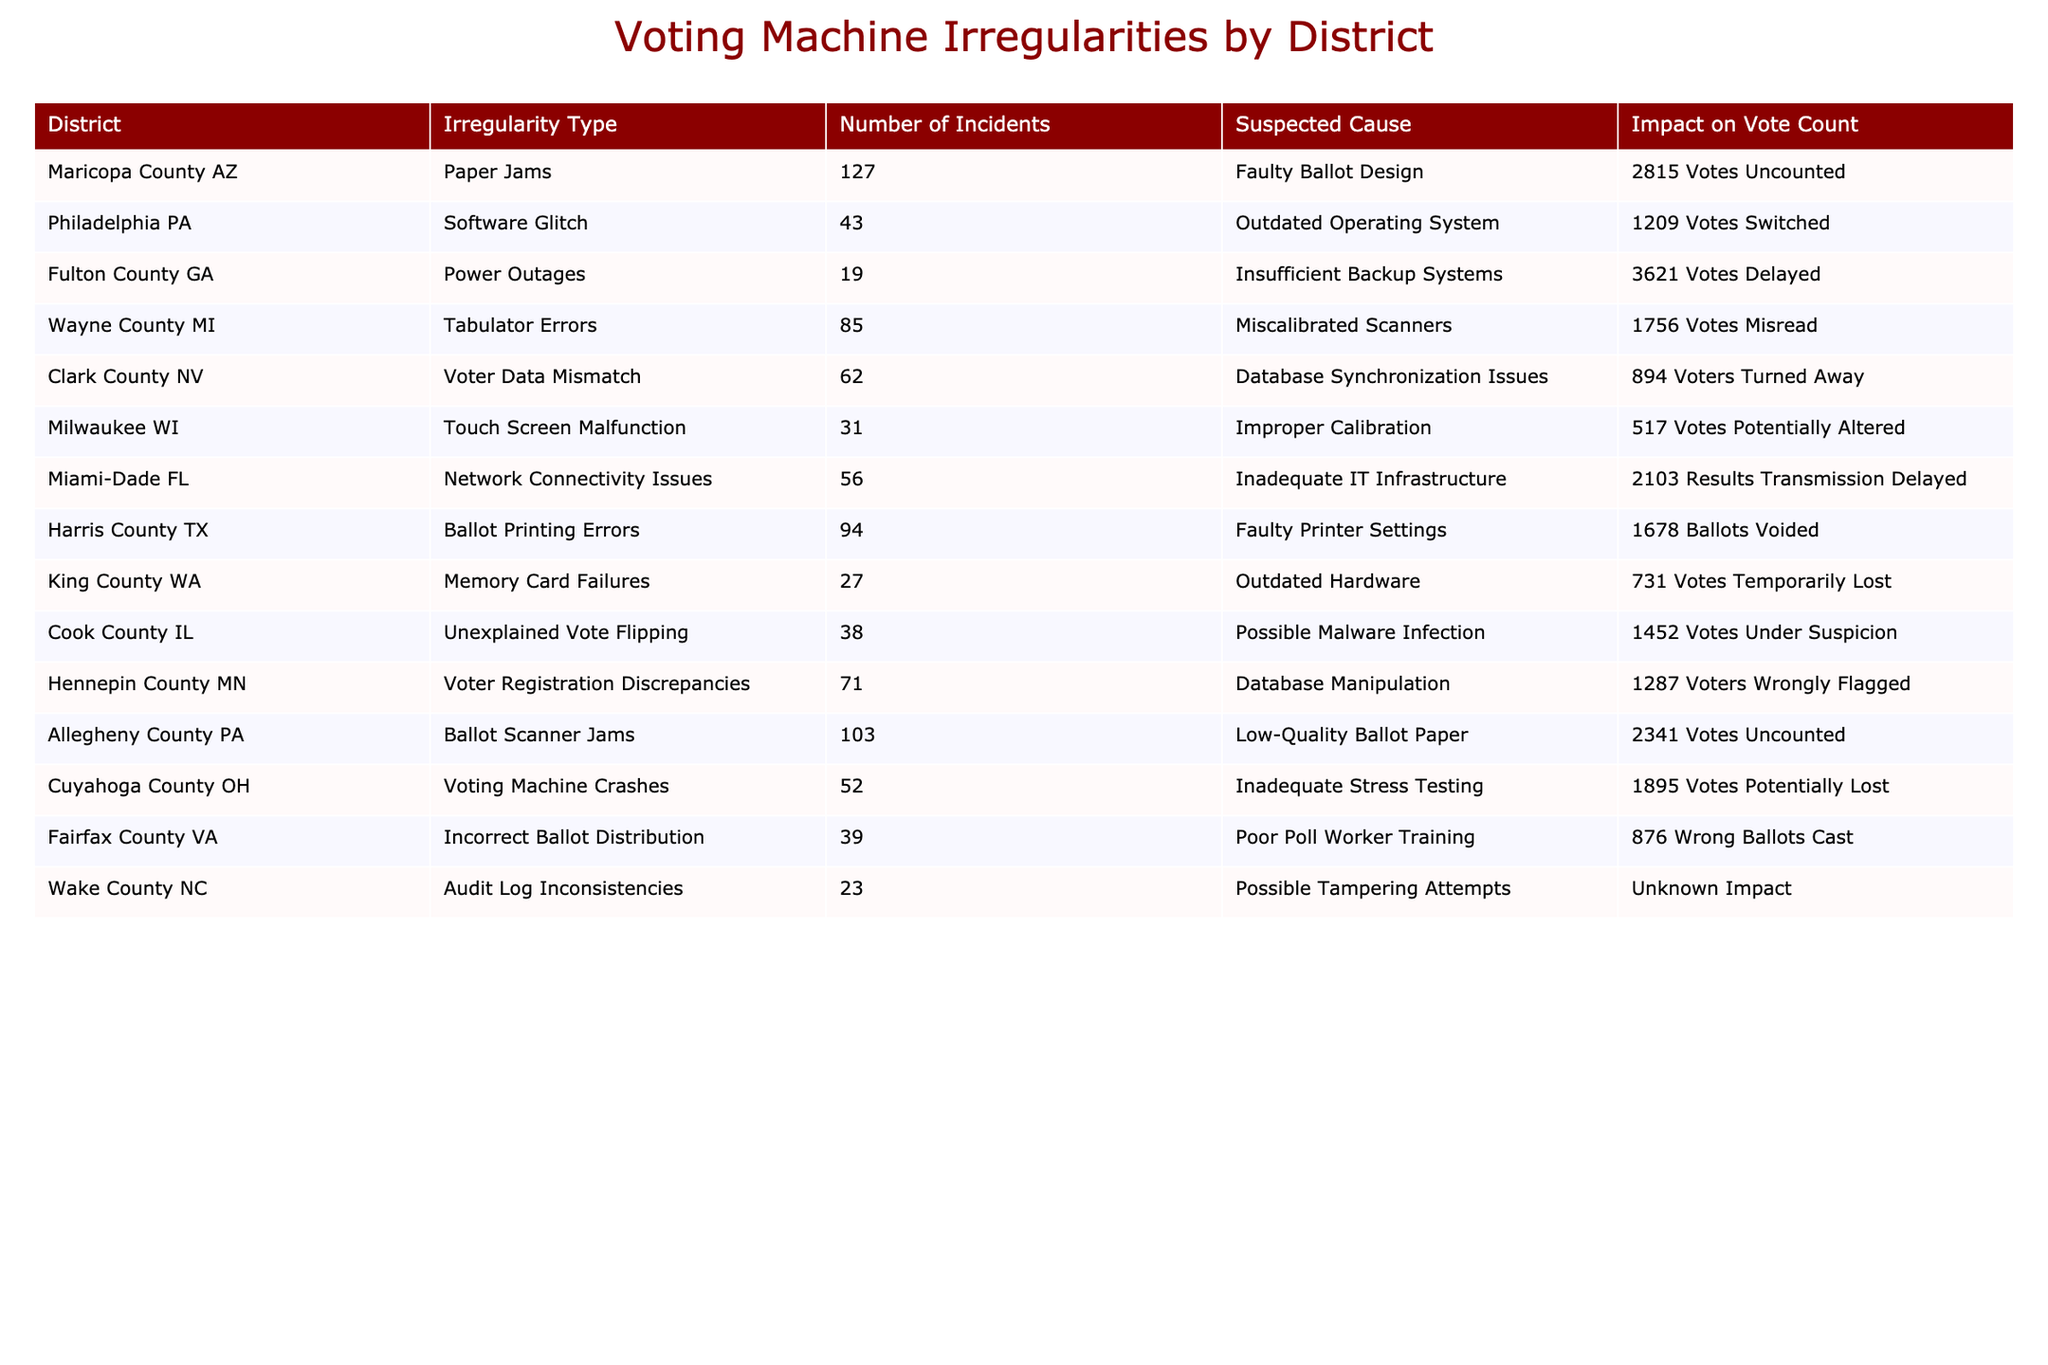What is the total number of voting incidents reported across all districts? To find the total number of voting incidents, I will sum the "Number of Incidents" column: 127 + 43 + 19 + 85 + 62 + 31 + 56 + 94 + 27 + 38 + 71 + 103 + 52 + 39 + 23 =  1030
Answer: 1030 Which district had the highest number of uncounted votes, and how many were uncounted? I will look for the highest value in the "Impact on Vote Count" column specifically for "Votes Uncounted." The highest value is 2815 from Maricopa County AZ.
Answer: Maricopa County AZ, 2815 Is there any district where the suspected cause uniquely relates to equipment malfunction? I check the "Suspected Cause" column for specific phrases that suggest equipment malfunction, such as "Power Outages" or "Touch Screen Malfunction." Upon review, both types are listed, suggesting multiple issues but confirm they are all related to equipment.
Answer: No How many total votes were potentially lost across districts due to incidents? I will sum the values in the "Impact on Vote Count" column that specifically mention "Votes Potentially Lost," which include Milwaukee WI (517) and Cuyahoga County OH (1895). The total is 517 + 1895 = 2412.
Answer: 2412 In how many districts were voters turned away, and what is the total impact on vote count for these districts? I will identify districts from the table where the "Impact on Vote Count" mentions "Voters Turned Away." Only Clark County NV shows this, with an impact of 894. Therefore, there is one district, and the total impact count is 894.
Answer: 1 district, 894 votes Is there a consistent suspected cause across multiple districts for vote irregularities? I will scan the "Suspected Cause" column for common phrases. "Outdated" appears only in the Software Glitch and Memory Card Failures rows, indicating not a strong consistent cause just the same issue in different forms.
Answer: No Which irregularity type had the most incidents, and how many were reported? I will look at the "Irregularity Type" column to count occurrences. The highest is Paper Jams at 127 incidents.
Answer: Paper Jams, 127 incidents What is the average number of incidents reported across all districts? I calculate the average by dividing the total number of incidents (1030) by the total number of districts (15): 1030 / 15 = 68.67.
Answer: 68.67 Are there any districts with an impact on vote count that is undefined or unknown? I review the "Impact on Vote Count" column for terms like "Unknown." Wake County NC has "Unknown Impact," indicating uncertainty in the count.
Answer: Yes How many incidents were reported for tabulator errors, and what was their impact on vote count? From the table, Wayne County MI shows a report of 85 incidents for tabulator errors, with an impact of 1756 Votes Misread.
Answer: 85 incidents, 1756 votes What districts experienced delays in results transmission, and how many were affected? I will check the "Impact on Vote Count" for "Results Transmission Delayed." Miami-Dade FL shows 2103 affected due to inadequate IT infrastructure.
Answer: Miami-Dade FL, 2103 votes 